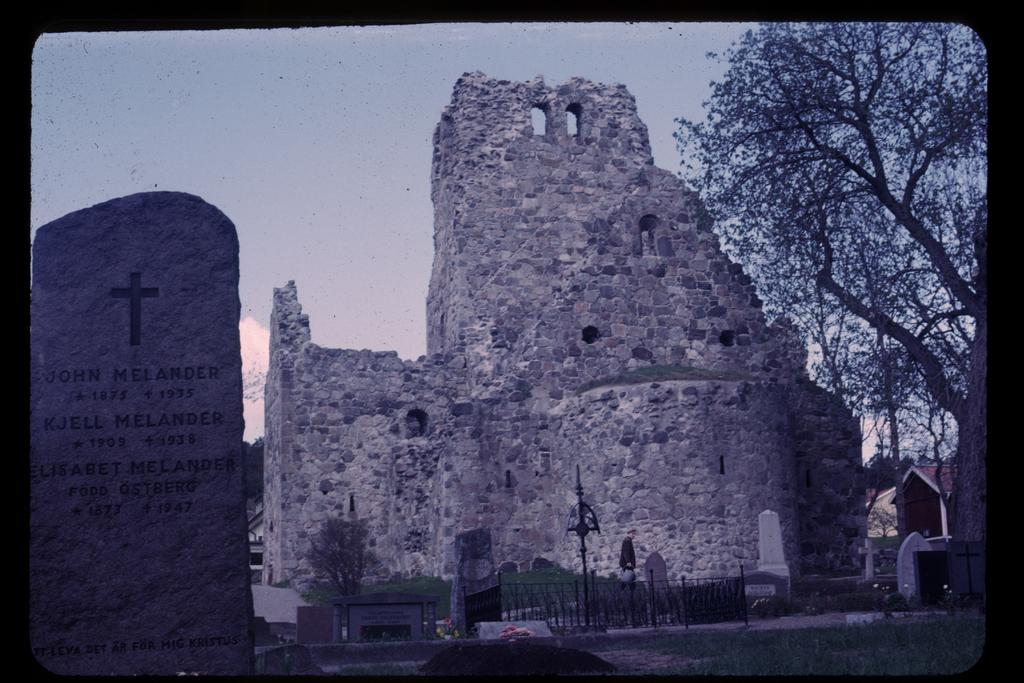What can be observed about the image's appearance? The image appears to be edited. What is the main subject in the foreground of the image? There is a gravestone in the image. What structure is visible in the background of the image? There is a fort visible behind the gravestone. What type of vegetation is on the right side of the image? There is a tree on the right side of the image. What is the taste of the tree on the right side of the image? Trees do not have a taste, so this question cannot be answered. 